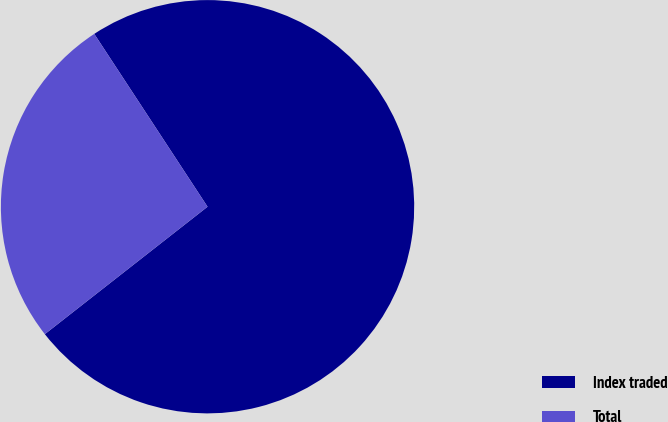<chart> <loc_0><loc_0><loc_500><loc_500><pie_chart><fcel>Index traded<fcel>Total<nl><fcel>73.66%<fcel>26.34%<nl></chart> 